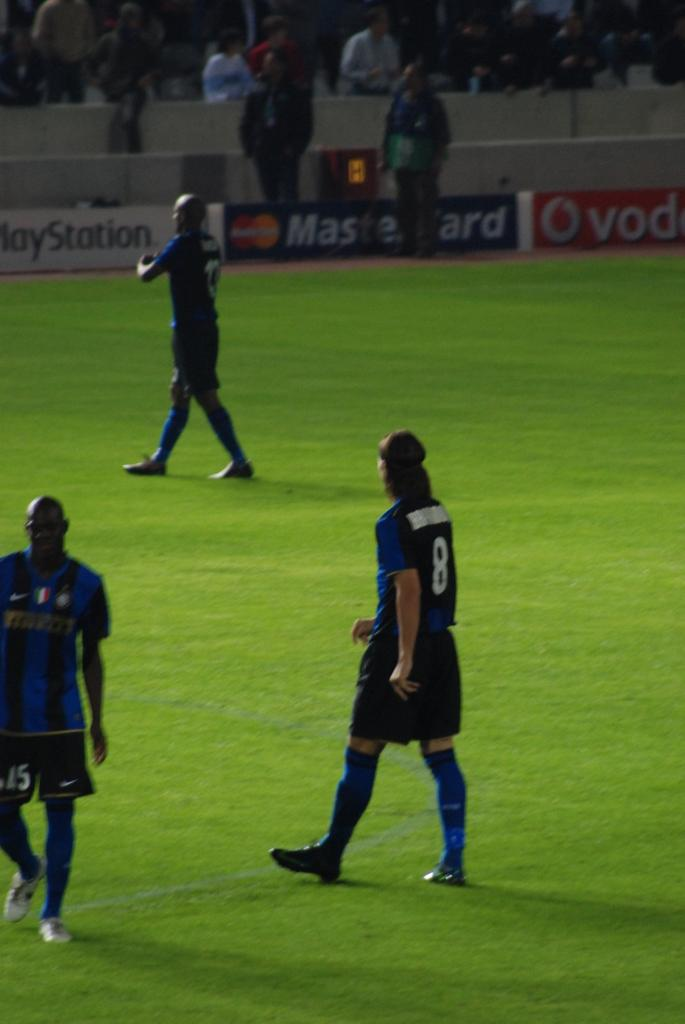<image>
Write a terse but informative summary of the picture. Banners advertising PlayStation and Mastercard line the walls at this football stadium. 